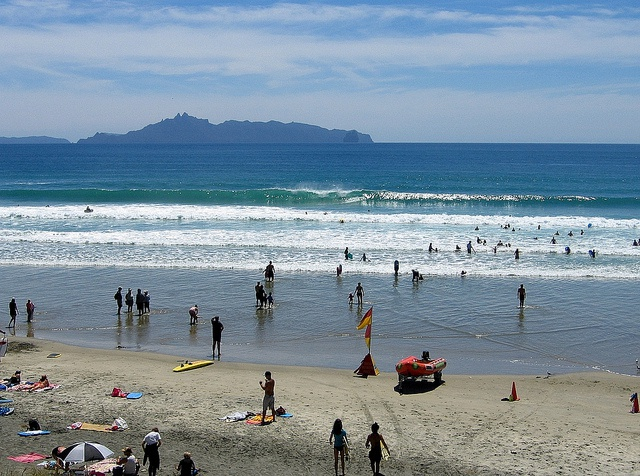Describe the objects in this image and their specific colors. I can see people in gray, black, darkgray, and lightgray tones, boat in gray, black, maroon, and salmon tones, umbrella in gray, black, darkgray, and lightgray tones, people in gray, black, and darkgray tones, and people in gray, black, and darkgray tones in this image. 